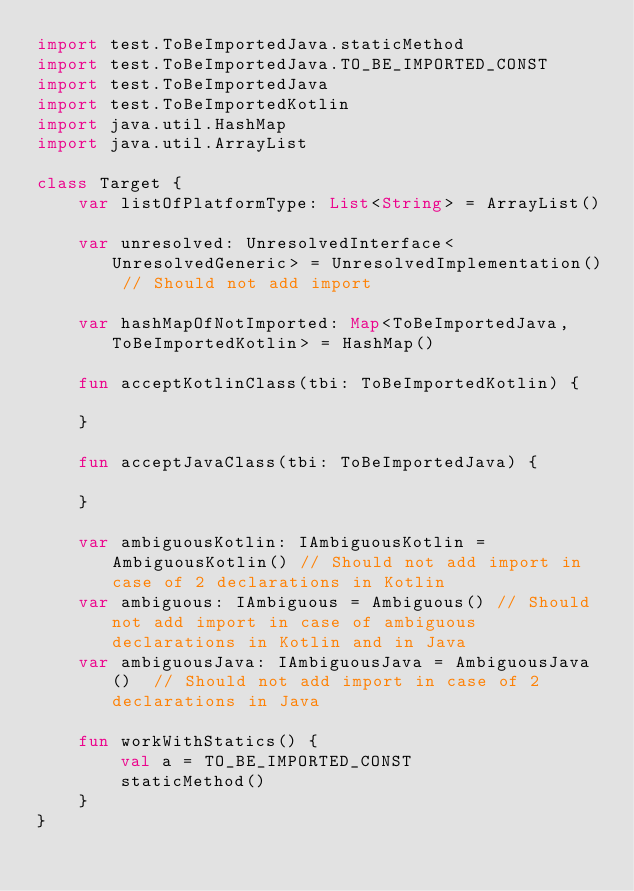Convert code to text. <code><loc_0><loc_0><loc_500><loc_500><_Kotlin_>import test.ToBeImportedJava.staticMethod
import test.ToBeImportedJava.TO_BE_IMPORTED_CONST
import test.ToBeImportedJava
import test.ToBeImportedKotlin
import java.util.HashMap
import java.util.ArrayList

class Target {
    var listOfPlatformType: List<String> = ArrayList()

    var unresolved: UnresolvedInterface<UnresolvedGeneric> = UnresolvedImplementation() // Should not add import

    var hashMapOfNotImported: Map<ToBeImportedJava, ToBeImportedKotlin> = HashMap()

    fun acceptKotlinClass(tbi: ToBeImportedKotlin) {

    }

    fun acceptJavaClass(tbi: ToBeImportedJava) {

    }

    var ambiguousKotlin: IAmbiguousKotlin = AmbiguousKotlin() // Should not add import in case of 2 declarations in Kotlin
    var ambiguous: IAmbiguous = Ambiguous() // Should not add import in case of ambiguous declarations in Kotlin and in Java
    var ambiguousJava: IAmbiguousJava = AmbiguousJava()  // Should not add import in case of 2 declarations in Java

    fun workWithStatics() {
        val a = TO_BE_IMPORTED_CONST
        staticMethod()
    }
}</code> 